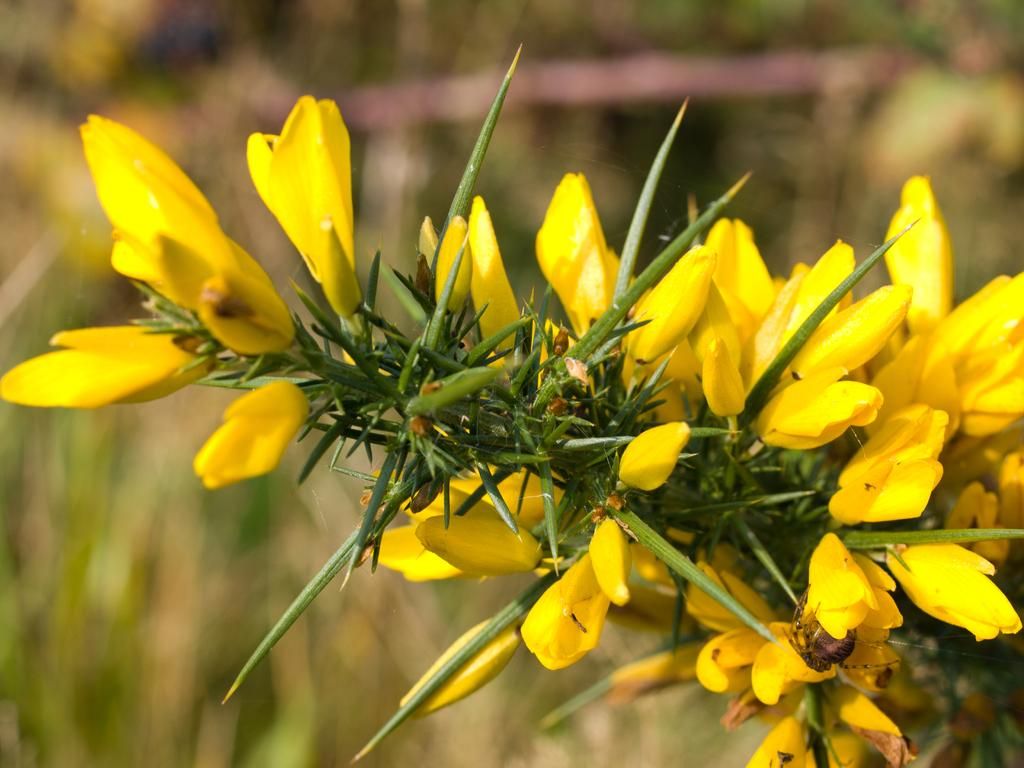What is the main subject of the image? The main subject of the image is a stem with leaves. What can be seen on the stem? There are yellow flowers and buds on the stem. Is there any wildlife present in the image? Yes, there is an insect on one of the flowers. How would you describe the background of the image? The background of the image is blurred. What level of the building can be seen in the image? There is no building present in the image; it features a stem with leaves, yellow flowers, buds, and an insect. How many trees are visible in the image? There is only one stem with leaves visible in the image, not an entire tree. 